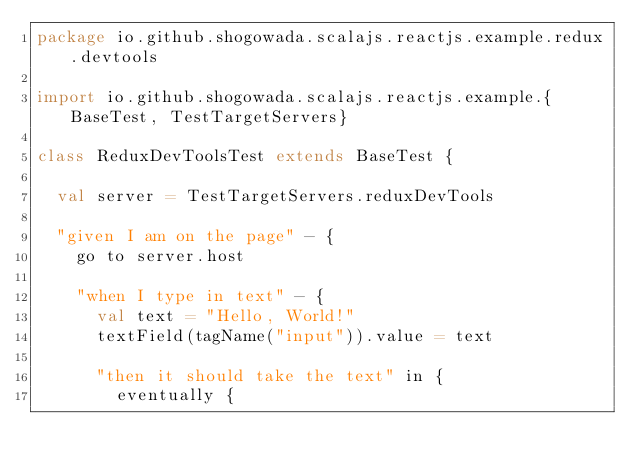<code> <loc_0><loc_0><loc_500><loc_500><_Scala_>package io.github.shogowada.scalajs.reactjs.example.redux.devtools

import io.github.shogowada.scalajs.reactjs.example.{BaseTest, TestTargetServers}

class ReduxDevToolsTest extends BaseTest {

  val server = TestTargetServers.reduxDevTools

  "given I am on the page" - {
    go to server.host

    "when I type in text" - {
      val text = "Hello, World!"
      textField(tagName("input")).value = text

      "then it should take the text" in {
        eventually {</code> 